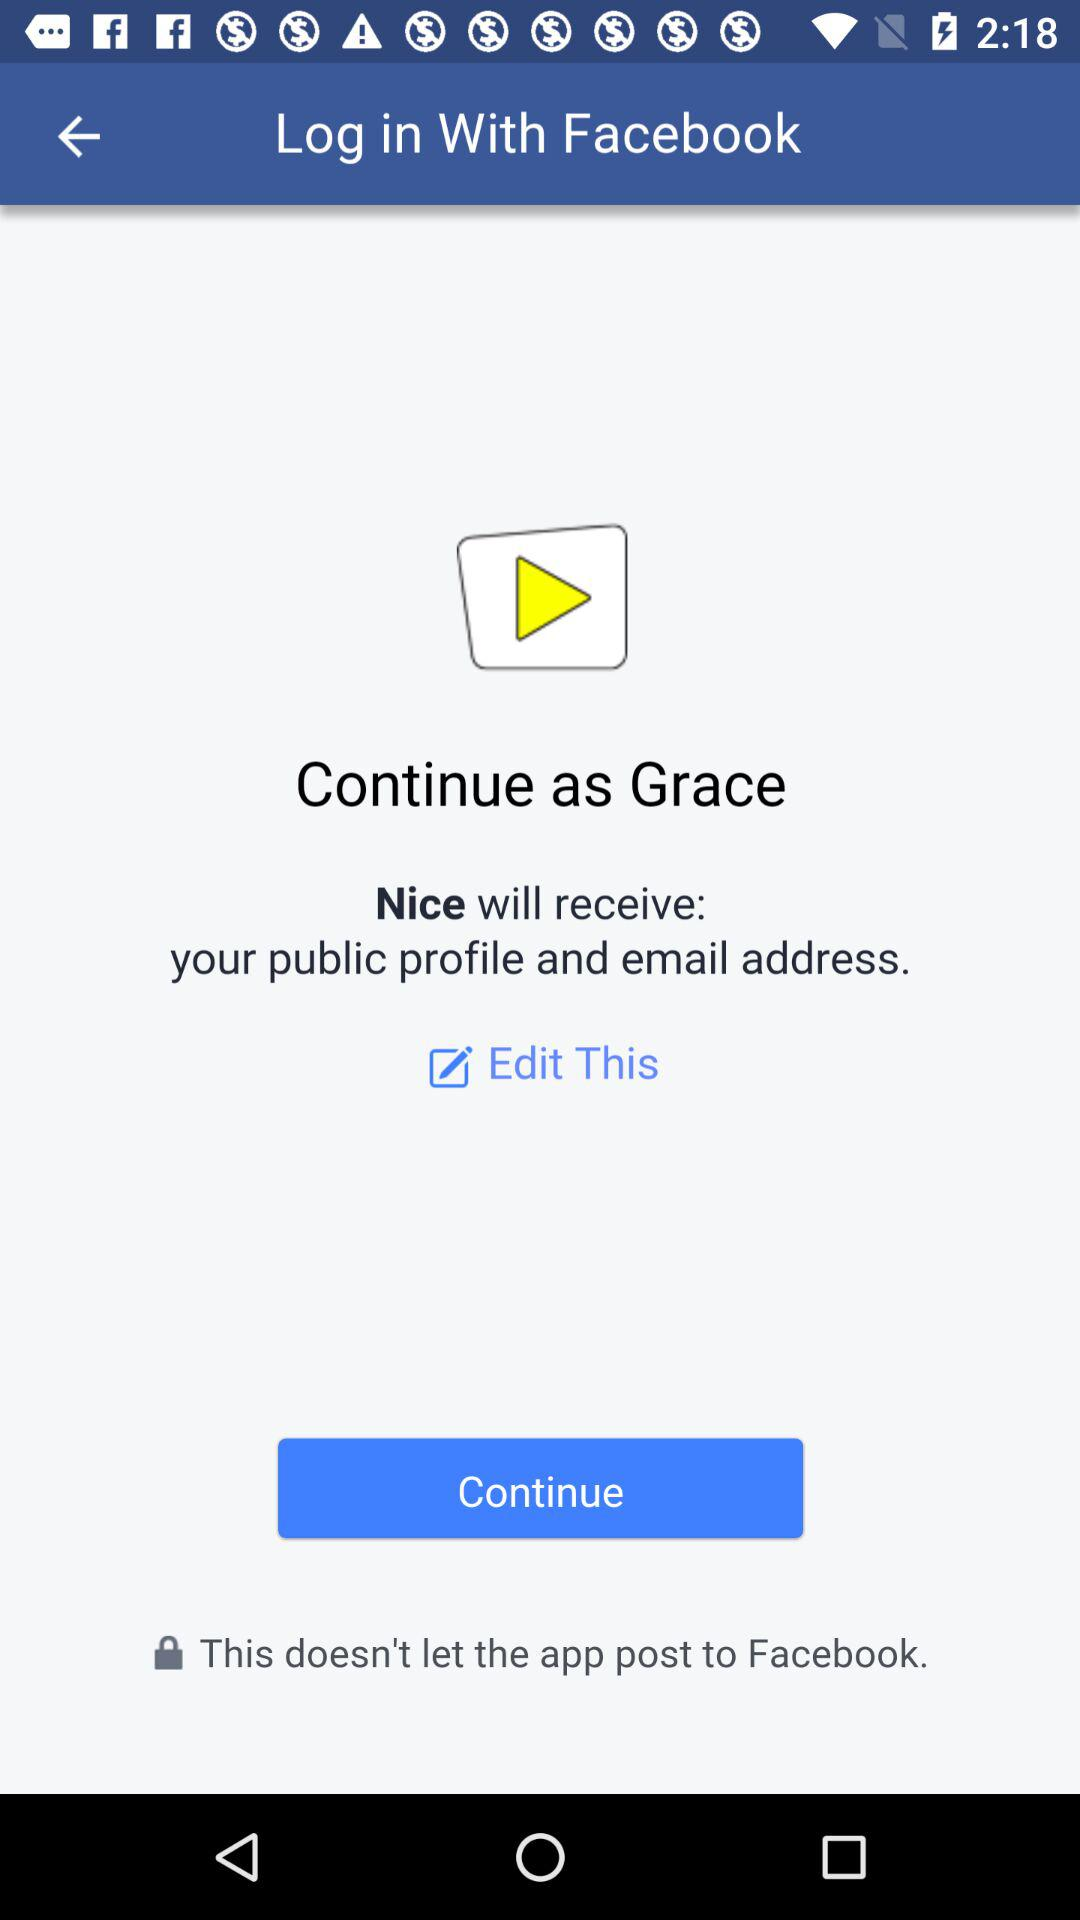How can we login? We can log in with Facebook. 